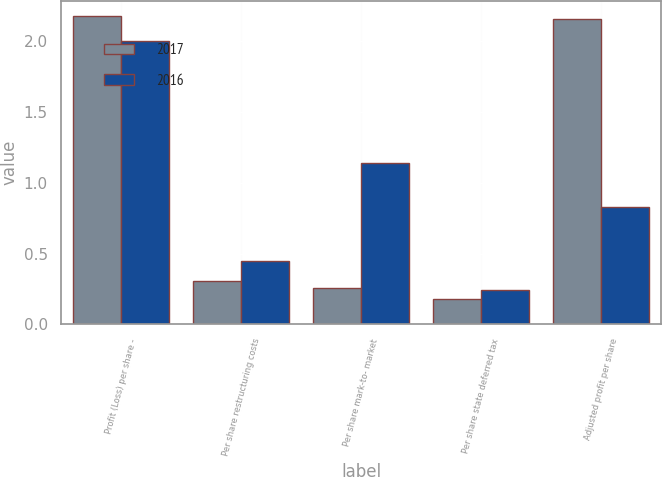Convert chart. <chart><loc_0><loc_0><loc_500><loc_500><stacked_bar_chart><ecel><fcel>Profit (Loss) per share -<fcel>Per share restructuring costs<fcel>Per share mark-to- market<fcel>Per share state deferred tax<fcel>Adjusted profit per share<nl><fcel>2017<fcel>2.18<fcel>0.31<fcel>0.26<fcel>0.18<fcel>2.16<nl><fcel>2016<fcel>2<fcel>0.45<fcel>1.14<fcel>0.24<fcel>0.83<nl></chart> 